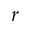Convert formula to latex. <formula><loc_0><loc_0><loc_500><loc_500>r</formula> 